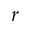Convert formula to latex. <formula><loc_0><loc_0><loc_500><loc_500>r</formula> 